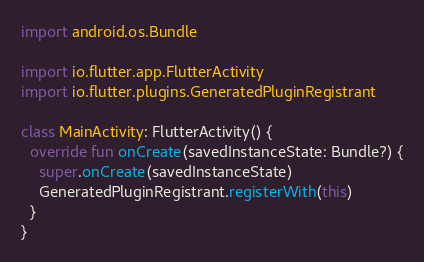<code> <loc_0><loc_0><loc_500><loc_500><_Kotlin_>
import android.os.Bundle

import io.flutter.app.FlutterActivity
import io.flutter.plugins.GeneratedPluginRegistrant

class MainActivity: FlutterActivity() {
  override fun onCreate(savedInstanceState: Bundle?) {
    super.onCreate(savedInstanceState)
    GeneratedPluginRegistrant.registerWith(this)
  }
}
</code> 